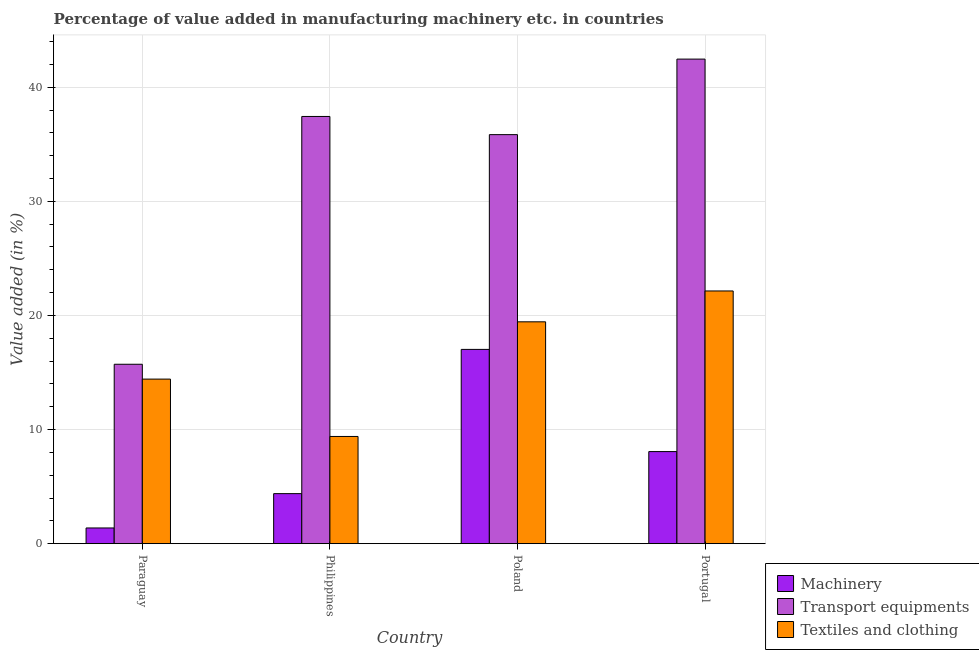How many different coloured bars are there?
Offer a very short reply. 3. How many groups of bars are there?
Your response must be concise. 4. Are the number of bars on each tick of the X-axis equal?
Your answer should be compact. Yes. How many bars are there on the 1st tick from the left?
Your answer should be compact. 3. How many bars are there on the 1st tick from the right?
Make the answer very short. 3. In how many cases, is the number of bars for a given country not equal to the number of legend labels?
Provide a succinct answer. 0. What is the value added in manufacturing machinery in Portugal?
Give a very brief answer. 8.07. Across all countries, what is the maximum value added in manufacturing textile and clothing?
Make the answer very short. 22.15. Across all countries, what is the minimum value added in manufacturing transport equipments?
Offer a very short reply. 15.72. In which country was the value added in manufacturing textile and clothing maximum?
Your response must be concise. Portugal. In which country was the value added in manufacturing machinery minimum?
Keep it short and to the point. Paraguay. What is the total value added in manufacturing textile and clothing in the graph?
Keep it short and to the point. 65.4. What is the difference between the value added in manufacturing machinery in Paraguay and that in Poland?
Provide a short and direct response. -15.65. What is the difference between the value added in manufacturing machinery in Portugal and the value added in manufacturing transport equipments in Poland?
Ensure brevity in your answer.  -27.78. What is the average value added in manufacturing machinery per country?
Keep it short and to the point. 7.71. What is the difference between the value added in manufacturing textile and clothing and value added in manufacturing transport equipments in Poland?
Your answer should be very brief. -16.41. What is the ratio of the value added in manufacturing machinery in Paraguay to that in Philippines?
Keep it short and to the point. 0.31. What is the difference between the highest and the second highest value added in manufacturing transport equipments?
Give a very brief answer. 5.03. What is the difference between the highest and the lowest value added in manufacturing transport equipments?
Your answer should be compact. 26.74. In how many countries, is the value added in manufacturing machinery greater than the average value added in manufacturing machinery taken over all countries?
Your answer should be compact. 2. Is the sum of the value added in manufacturing machinery in Philippines and Portugal greater than the maximum value added in manufacturing textile and clothing across all countries?
Provide a succinct answer. No. What does the 2nd bar from the left in Philippines represents?
Your answer should be compact. Transport equipments. What does the 2nd bar from the right in Poland represents?
Offer a terse response. Transport equipments. Are all the bars in the graph horizontal?
Offer a terse response. No. How many countries are there in the graph?
Make the answer very short. 4. Are the values on the major ticks of Y-axis written in scientific E-notation?
Keep it short and to the point. No. Where does the legend appear in the graph?
Provide a succinct answer. Bottom right. What is the title of the graph?
Provide a succinct answer. Percentage of value added in manufacturing machinery etc. in countries. Does "Private sector" appear as one of the legend labels in the graph?
Provide a succinct answer. No. What is the label or title of the X-axis?
Offer a very short reply. Country. What is the label or title of the Y-axis?
Offer a very short reply. Value added (in %). What is the Value added (in %) of Machinery in Paraguay?
Your answer should be compact. 1.38. What is the Value added (in %) of Transport equipments in Paraguay?
Your answer should be compact. 15.72. What is the Value added (in %) in Textiles and clothing in Paraguay?
Make the answer very short. 14.42. What is the Value added (in %) of Machinery in Philippines?
Make the answer very short. 4.38. What is the Value added (in %) of Transport equipments in Philippines?
Provide a succinct answer. 37.44. What is the Value added (in %) in Textiles and clothing in Philippines?
Ensure brevity in your answer.  9.39. What is the Value added (in %) in Machinery in Poland?
Provide a succinct answer. 17.03. What is the Value added (in %) in Transport equipments in Poland?
Provide a short and direct response. 35.85. What is the Value added (in %) in Textiles and clothing in Poland?
Your response must be concise. 19.44. What is the Value added (in %) of Machinery in Portugal?
Ensure brevity in your answer.  8.07. What is the Value added (in %) in Transport equipments in Portugal?
Keep it short and to the point. 42.47. What is the Value added (in %) in Textiles and clothing in Portugal?
Ensure brevity in your answer.  22.15. Across all countries, what is the maximum Value added (in %) in Machinery?
Offer a terse response. 17.03. Across all countries, what is the maximum Value added (in %) of Transport equipments?
Give a very brief answer. 42.47. Across all countries, what is the maximum Value added (in %) of Textiles and clothing?
Provide a succinct answer. 22.15. Across all countries, what is the minimum Value added (in %) of Machinery?
Give a very brief answer. 1.38. Across all countries, what is the minimum Value added (in %) in Transport equipments?
Give a very brief answer. 15.72. Across all countries, what is the minimum Value added (in %) in Textiles and clothing?
Keep it short and to the point. 9.39. What is the total Value added (in %) of Machinery in the graph?
Make the answer very short. 30.85. What is the total Value added (in %) in Transport equipments in the graph?
Your answer should be compact. 131.47. What is the total Value added (in %) of Textiles and clothing in the graph?
Keep it short and to the point. 65.4. What is the difference between the Value added (in %) in Machinery in Paraguay and that in Philippines?
Your response must be concise. -3.01. What is the difference between the Value added (in %) in Transport equipments in Paraguay and that in Philippines?
Give a very brief answer. -21.72. What is the difference between the Value added (in %) of Textiles and clothing in Paraguay and that in Philippines?
Provide a short and direct response. 5.03. What is the difference between the Value added (in %) of Machinery in Paraguay and that in Poland?
Keep it short and to the point. -15.65. What is the difference between the Value added (in %) in Transport equipments in Paraguay and that in Poland?
Give a very brief answer. -20.12. What is the difference between the Value added (in %) in Textiles and clothing in Paraguay and that in Poland?
Your answer should be compact. -5.02. What is the difference between the Value added (in %) of Machinery in Paraguay and that in Portugal?
Make the answer very short. -6.69. What is the difference between the Value added (in %) in Transport equipments in Paraguay and that in Portugal?
Ensure brevity in your answer.  -26.74. What is the difference between the Value added (in %) in Textiles and clothing in Paraguay and that in Portugal?
Provide a short and direct response. -7.72. What is the difference between the Value added (in %) of Machinery in Philippines and that in Poland?
Offer a very short reply. -12.64. What is the difference between the Value added (in %) in Transport equipments in Philippines and that in Poland?
Your response must be concise. 1.59. What is the difference between the Value added (in %) of Textiles and clothing in Philippines and that in Poland?
Your response must be concise. -10.05. What is the difference between the Value added (in %) in Machinery in Philippines and that in Portugal?
Provide a succinct answer. -3.68. What is the difference between the Value added (in %) in Transport equipments in Philippines and that in Portugal?
Your answer should be compact. -5.03. What is the difference between the Value added (in %) of Textiles and clothing in Philippines and that in Portugal?
Keep it short and to the point. -12.75. What is the difference between the Value added (in %) in Machinery in Poland and that in Portugal?
Make the answer very short. 8.96. What is the difference between the Value added (in %) of Transport equipments in Poland and that in Portugal?
Make the answer very short. -6.62. What is the difference between the Value added (in %) in Textiles and clothing in Poland and that in Portugal?
Ensure brevity in your answer.  -2.71. What is the difference between the Value added (in %) of Machinery in Paraguay and the Value added (in %) of Transport equipments in Philippines?
Make the answer very short. -36.06. What is the difference between the Value added (in %) of Machinery in Paraguay and the Value added (in %) of Textiles and clothing in Philippines?
Make the answer very short. -8.02. What is the difference between the Value added (in %) of Transport equipments in Paraguay and the Value added (in %) of Textiles and clothing in Philippines?
Make the answer very short. 6.33. What is the difference between the Value added (in %) in Machinery in Paraguay and the Value added (in %) in Transport equipments in Poland?
Offer a terse response. -34.47. What is the difference between the Value added (in %) in Machinery in Paraguay and the Value added (in %) in Textiles and clothing in Poland?
Ensure brevity in your answer.  -18.07. What is the difference between the Value added (in %) in Transport equipments in Paraguay and the Value added (in %) in Textiles and clothing in Poland?
Keep it short and to the point. -3.72. What is the difference between the Value added (in %) in Machinery in Paraguay and the Value added (in %) in Transport equipments in Portugal?
Offer a very short reply. -41.09. What is the difference between the Value added (in %) of Machinery in Paraguay and the Value added (in %) of Textiles and clothing in Portugal?
Make the answer very short. -20.77. What is the difference between the Value added (in %) of Transport equipments in Paraguay and the Value added (in %) of Textiles and clothing in Portugal?
Provide a succinct answer. -6.42. What is the difference between the Value added (in %) of Machinery in Philippines and the Value added (in %) of Transport equipments in Poland?
Ensure brevity in your answer.  -31.46. What is the difference between the Value added (in %) in Machinery in Philippines and the Value added (in %) in Textiles and clothing in Poland?
Give a very brief answer. -15.06. What is the difference between the Value added (in %) of Transport equipments in Philippines and the Value added (in %) of Textiles and clothing in Poland?
Your answer should be compact. 18. What is the difference between the Value added (in %) in Machinery in Philippines and the Value added (in %) in Transport equipments in Portugal?
Your answer should be very brief. -38.08. What is the difference between the Value added (in %) in Machinery in Philippines and the Value added (in %) in Textiles and clothing in Portugal?
Offer a very short reply. -17.76. What is the difference between the Value added (in %) of Transport equipments in Philippines and the Value added (in %) of Textiles and clothing in Portugal?
Your answer should be very brief. 15.29. What is the difference between the Value added (in %) in Machinery in Poland and the Value added (in %) in Transport equipments in Portugal?
Give a very brief answer. -25.44. What is the difference between the Value added (in %) of Machinery in Poland and the Value added (in %) of Textiles and clothing in Portugal?
Keep it short and to the point. -5.12. What is the difference between the Value added (in %) of Transport equipments in Poland and the Value added (in %) of Textiles and clothing in Portugal?
Offer a terse response. 13.7. What is the average Value added (in %) of Machinery per country?
Provide a succinct answer. 7.71. What is the average Value added (in %) of Transport equipments per country?
Keep it short and to the point. 32.87. What is the average Value added (in %) in Textiles and clothing per country?
Your answer should be compact. 16.35. What is the difference between the Value added (in %) in Machinery and Value added (in %) in Transport equipments in Paraguay?
Your answer should be compact. -14.35. What is the difference between the Value added (in %) of Machinery and Value added (in %) of Textiles and clothing in Paraguay?
Offer a very short reply. -13.05. What is the difference between the Value added (in %) of Transport equipments and Value added (in %) of Textiles and clothing in Paraguay?
Offer a terse response. 1.3. What is the difference between the Value added (in %) of Machinery and Value added (in %) of Transport equipments in Philippines?
Offer a very short reply. -33.05. What is the difference between the Value added (in %) in Machinery and Value added (in %) in Textiles and clothing in Philippines?
Your response must be concise. -5.01. What is the difference between the Value added (in %) in Transport equipments and Value added (in %) in Textiles and clothing in Philippines?
Offer a very short reply. 28.04. What is the difference between the Value added (in %) in Machinery and Value added (in %) in Transport equipments in Poland?
Your answer should be compact. -18.82. What is the difference between the Value added (in %) in Machinery and Value added (in %) in Textiles and clothing in Poland?
Give a very brief answer. -2.42. What is the difference between the Value added (in %) of Transport equipments and Value added (in %) of Textiles and clothing in Poland?
Provide a short and direct response. 16.41. What is the difference between the Value added (in %) in Machinery and Value added (in %) in Transport equipments in Portugal?
Make the answer very short. -34.4. What is the difference between the Value added (in %) in Machinery and Value added (in %) in Textiles and clothing in Portugal?
Give a very brief answer. -14.08. What is the difference between the Value added (in %) of Transport equipments and Value added (in %) of Textiles and clothing in Portugal?
Your answer should be compact. 20.32. What is the ratio of the Value added (in %) of Machinery in Paraguay to that in Philippines?
Your answer should be very brief. 0.31. What is the ratio of the Value added (in %) in Transport equipments in Paraguay to that in Philippines?
Keep it short and to the point. 0.42. What is the ratio of the Value added (in %) of Textiles and clothing in Paraguay to that in Philippines?
Offer a terse response. 1.54. What is the ratio of the Value added (in %) in Machinery in Paraguay to that in Poland?
Offer a very short reply. 0.08. What is the ratio of the Value added (in %) in Transport equipments in Paraguay to that in Poland?
Provide a short and direct response. 0.44. What is the ratio of the Value added (in %) in Textiles and clothing in Paraguay to that in Poland?
Provide a short and direct response. 0.74. What is the ratio of the Value added (in %) in Machinery in Paraguay to that in Portugal?
Offer a very short reply. 0.17. What is the ratio of the Value added (in %) of Transport equipments in Paraguay to that in Portugal?
Give a very brief answer. 0.37. What is the ratio of the Value added (in %) of Textiles and clothing in Paraguay to that in Portugal?
Keep it short and to the point. 0.65. What is the ratio of the Value added (in %) in Machinery in Philippines to that in Poland?
Your answer should be very brief. 0.26. What is the ratio of the Value added (in %) in Transport equipments in Philippines to that in Poland?
Make the answer very short. 1.04. What is the ratio of the Value added (in %) of Textiles and clothing in Philippines to that in Poland?
Keep it short and to the point. 0.48. What is the ratio of the Value added (in %) in Machinery in Philippines to that in Portugal?
Your answer should be compact. 0.54. What is the ratio of the Value added (in %) of Transport equipments in Philippines to that in Portugal?
Offer a terse response. 0.88. What is the ratio of the Value added (in %) in Textiles and clothing in Philippines to that in Portugal?
Offer a very short reply. 0.42. What is the ratio of the Value added (in %) in Machinery in Poland to that in Portugal?
Your response must be concise. 2.11. What is the ratio of the Value added (in %) of Transport equipments in Poland to that in Portugal?
Ensure brevity in your answer.  0.84. What is the ratio of the Value added (in %) of Textiles and clothing in Poland to that in Portugal?
Your response must be concise. 0.88. What is the difference between the highest and the second highest Value added (in %) of Machinery?
Your answer should be very brief. 8.96. What is the difference between the highest and the second highest Value added (in %) of Transport equipments?
Your answer should be compact. 5.03. What is the difference between the highest and the second highest Value added (in %) in Textiles and clothing?
Give a very brief answer. 2.71. What is the difference between the highest and the lowest Value added (in %) in Machinery?
Your answer should be compact. 15.65. What is the difference between the highest and the lowest Value added (in %) of Transport equipments?
Ensure brevity in your answer.  26.74. What is the difference between the highest and the lowest Value added (in %) in Textiles and clothing?
Your answer should be compact. 12.75. 